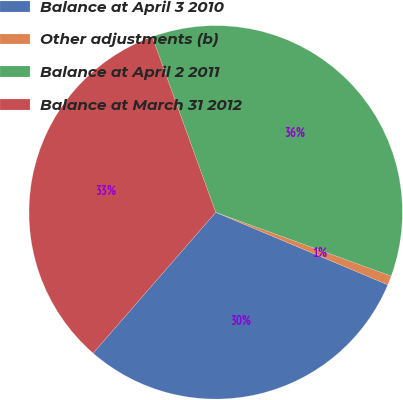<chart> <loc_0><loc_0><loc_500><loc_500><pie_chart><fcel>Balance at April 3 2010<fcel>Other adjustments (b)<fcel>Balance at April 2 2011<fcel>Balance at March 31 2012<nl><fcel>30.06%<fcel>0.8%<fcel>36.07%<fcel>33.07%<nl></chart> 